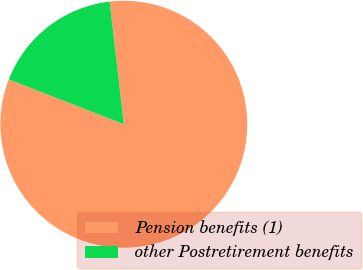<chart> <loc_0><loc_0><loc_500><loc_500><pie_chart><fcel>Pension benefits (1)<fcel>other Postretirement benefits<nl><fcel>82.74%<fcel>17.26%<nl></chart> 